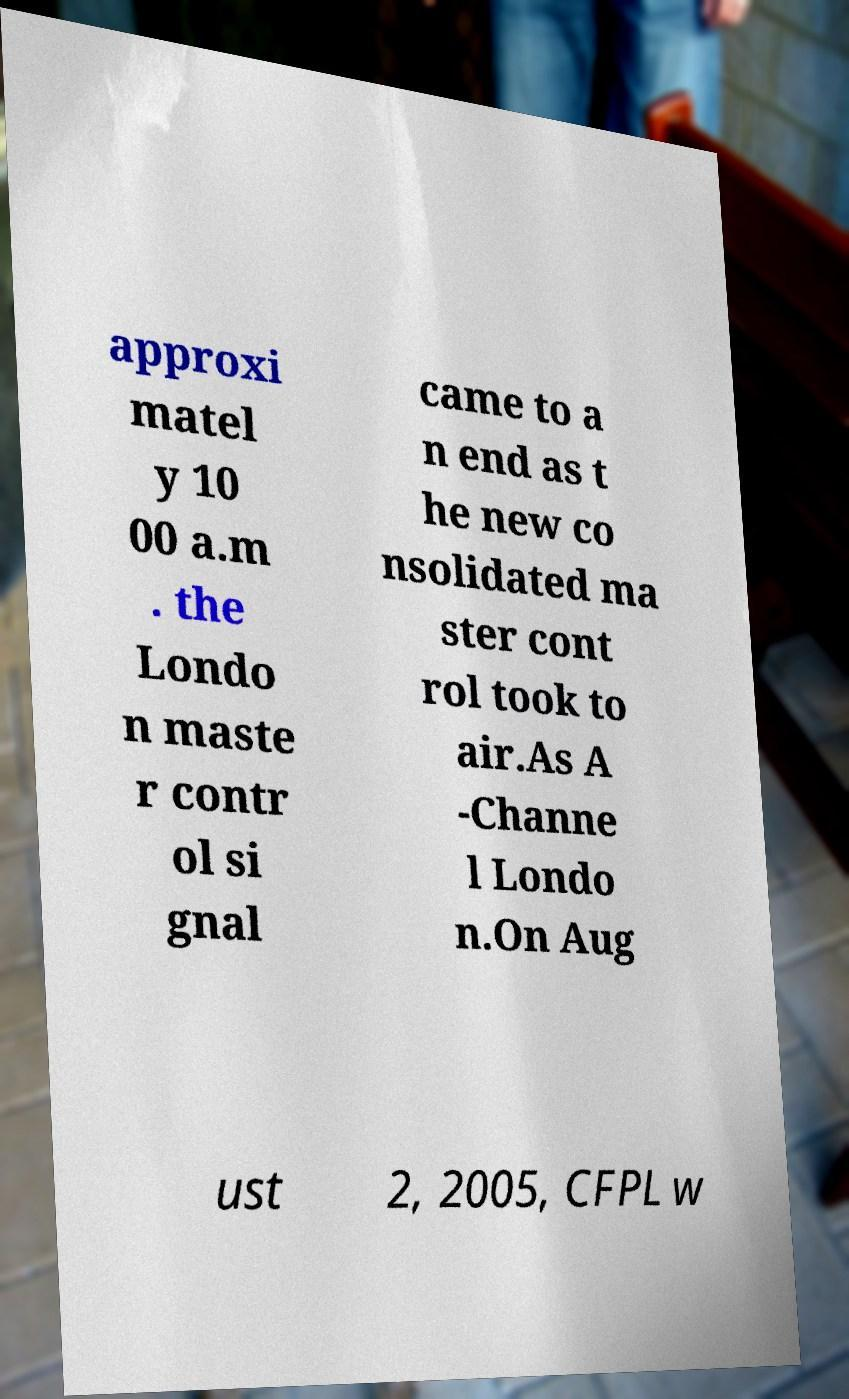There's text embedded in this image that I need extracted. Can you transcribe it verbatim? approxi matel y 10 00 a.m . the Londo n maste r contr ol si gnal came to a n end as t he new co nsolidated ma ster cont rol took to air.As A -Channe l Londo n.On Aug ust 2, 2005, CFPL w 